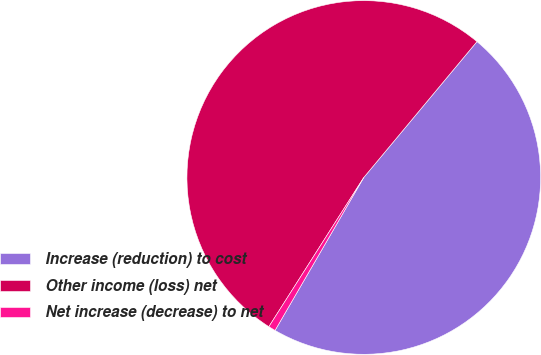Convert chart. <chart><loc_0><loc_0><loc_500><loc_500><pie_chart><fcel>Increase (reduction) to cost<fcel>Other income (loss) net<fcel>Net increase (decrease) to net<nl><fcel>47.31%<fcel>52.04%<fcel>0.65%<nl></chart> 